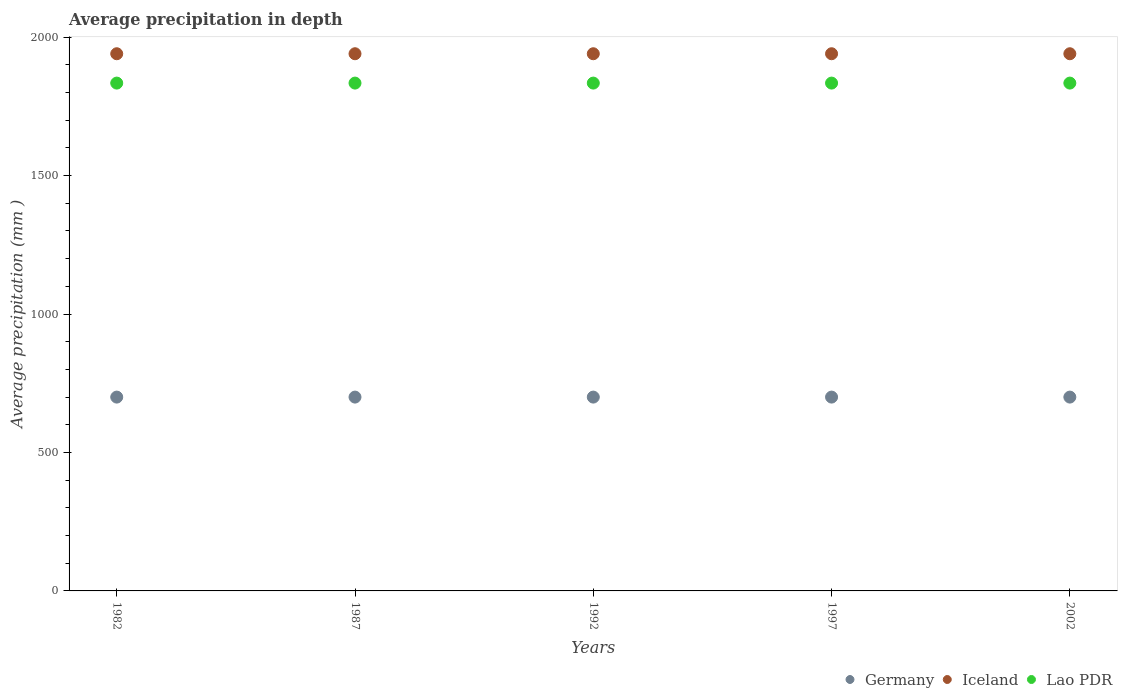What is the average precipitation in Lao PDR in 2002?
Your answer should be compact. 1834. Across all years, what is the maximum average precipitation in Lao PDR?
Ensure brevity in your answer.  1834. Across all years, what is the minimum average precipitation in Iceland?
Offer a very short reply. 1940. In which year was the average precipitation in Germany maximum?
Your answer should be compact. 1982. In which year was the average precipitation in Lao PDR minimum?
Your answer should be very brief. 1982. What is the total average precipitation in Iceland in the graph?
Your answer should be very brief. 9700. What is the difference between the average precipitation in Iceland in 1982 and that in 1997?
Make the answer very short. 0. What is the difference between the average precipitation in Lao PDR in 2002 and the average precipitation in Iceland in 1982?
Provide a short and direct response. -106. What is the average average precipitation in Iceland per year?
Your answer should be very brief. 1940. In the year 1992, what is the difference between the average precipitation in Germany and average precipitation in Iceland?
Your answer should be compact. -1240. In how many years, is the average precipitation in Iceland greater than 1400 mm?
Offer a very short reply. 5. Is the average precipitation in Iceland in 1982 less than that in 1987?
Provide a short and direct response. No. Is the difference between the average precipitation in Germany in 1982 and 1987 greater than the difference between the average precipitation in Iceland in 1982 and 1987?
Provide a succinct answer. No. What is the difference between the highest and the lowest average precipitation in Germany?
Your response must be concise. 0. In how many years, is the average precipitation in Iceland greater than the average average precipitation in Iceland taken over all years?
Your answer should be very brief. 0. Does the average precipitation in Iceland monotonically increase over the years?
Ensure brevity in your answer.  No. Is the average precipitation in Lao PDR strictly greater than the average precipitation in Iceland over the years?
Provide a succinct answer. No. Is the average precipitation in Lao PDR strictly less than the average precipitation in Germany over the years?
Your answer should be very brief. No. Are the values on the major ticks of Y-axis written in scientific E-notation?
Make the answer very short. No. Where does the legend appear in the graph?
Keep it short and to the point. Bottom right. How many legend labels are there?
Offer a very short reply. 3. What is the title of the graph?
Keep it short and to the point. Average precipitation in depth. Does "Ecuador" appear as one of the legend labels in the graph?
Make the answer very short. No. What is the label or title of the Y-axis?
Give a very brief answer. Average precipitation (mm ). What is the Average precipitation (mm ) of Germany in 1982?
Give a very brief answer. 700. What is the Average precipitation (mm ) in Iceland in 1982?
Your answer should be very brief. 1940. What is the Average precipitation (mm ) of Lao PDR in 1982?
Your answer should be compact. 1834. What is the Average precipitation (mm ) in Germany in 1987?
Your answer should be compact. 700. What is the Average precipitation (mm ) of Iceland in 1987?
Your answer should be compact. 1940. What is the Average precipitation (mm ) of Lao PDR in 1987?
Make the answer very short. 1834. What is the Average precipitation (mm ) of Germany in 1992?
Give a very brief answer. 700. What is the Average precipitation (mm ) of Iceland in 1992?
Your response must be concise. 1940. What is the Average precipitation (mm ) in Lao PDR in 1992?
Offer a very short reply. 1834. What is the Average precipitation (mm ) in Germany in 1997?
Make the answer very short. 700. What is the Average precipitation (mm ) in Iceland in 1997?
Your answer should be compact. 1940. What is the Average precipitation (mm ) of Lao PDR in 1997?
Give a very brief answer. 1834. What is the Average precipitation (mm ) of Germany in 2002?
Give a very brief answer. 700. What is the Average precipitation (mm ) of Iceland in 2002?
Offer a terse response. 1940. What is the Average precipitation (mm ) in Lao PDR in 2002?
Offer a terse response. 1834. Across all years, what is the maximum Average precipitation (mm ) of Germany?
Offer a terse response. 700. Across all years, what is the maximum Average precipitation (mm ) in Iceland?
Offer a very short reply. 1940. Across all years, what is the maximum Average precipitation (mm ) in Lao PDR?
Your answer should be compact. 1834. Across all years, what is the minimum Average precipitation (mm ) of Germany?
Keep it short and to the point. 700. Across all years, what is the minimum Average precipitation (mm ) of Iceland?
Give a very brief answer. 1940. Across all years, what is the minimum Average precipitation (mm ) in Lao PDR?
Provide a short and direct response. 1834. What is the total Average precipitation (mm ) of Germany in the graph?
Offer a very short reply. 3500. What is the total Average precipitation (mm ) in Iceland in the graph?
Make the answer very short. 9700. What is the total Average precipitation (mm ) of Lao PDR in the graph?
Offer a terse response. 9170. What is the difference between the Average precipitation (mm ) of Germany in 1982 and that in 1987?
Your answer should be compact. 0. What is the difference between the Average precipitation (mm ) in Iceland in 1982 and that in 1987?
Offer a terse response. 0. What is the difference between the Average precipitation (mm ) of Iceland in 1982 and that in 1992?
Your answer should be very brief. 0. What is the difference between the Average precipitation (mm ) in Iceland in 1982 and that in 1997?
Your response must be concise. 0. What is the difference between the Average precipitation (mm ) in Germany in 1982 and that in 2002?
Provide a short and direct response. 0. What is the difference between the Average precipitation (mm ) in Iceland in 1982 and that in 2002?
Offer a very short reply. 0. What is the difference between the Average precipitation (mm ) in Lao PDR in 1982 and that in 2002?
Ensure brevity in your answer.  0. What is the difference between the Average precipitation (mm ) in Germany in 1987 and that in 1992?
Offer a very short reply. 0. What is the difference between the Average precipitation (mm ) in Iceland in 1987 and that in 1992?
Offer a terse response. 0. What is the difference between the Average precipitation (mm ) in Lao PDR in 1987 and that in 1992?
Ensure brevity in your answer.  0. What is the difference between the Average precipitation (mm ) of Iceland in 1987 and that in 1997?
Your answer should be very brief. 0. What is the difference between the Average precipitation (mm ) of Lao PDR in 1987 and that in 2002?
Ensure brevity in your answer.  0. What is the difference between the Average precipitation (mm ) of Germany in 1992 and that in 1997?
Provide a succinct answer. 0. What is the difference between the Average precipitation (mm ) in Iceland in 1992 and that in 2002?
Make the answer very short. 0. What is the difference between the Average precipitation (mm ) of Germany in 1997 and that in 2002?
Provide a succinct answer. 0. What is the difference between the Average precipitation (mm ) in Lao PDR in 1997 and that in 2002?
Provide a succinct answer. 0. What is the difference between the Average precipitation (mm ) of Germany in 1982 and the Average precipitation (mm ) of Iceland in 1987?
Your answer should be very brief. -1240. What is the difference between the Average precipitation (mm ) of Germany in 1982 and the Average precipitation (mm ) of Lao PDR in 1987?
Give a very brief answer. -1134. What is the difference between the Average precipitation (mm ) in Iceland in 1982 and the Average precipitation (mm ) in Lao PDR in 1987?
Provide a short and direct response. 106. What is the difference between the Average precipitation (mm ) in Germany in 1982 and the Average precipitation (mm ) in Iceland in 1992?
Offer a terse response. -1240. What is the difference between the Average precipitation (mm ) in Germany in 1982 and the Average precipitation (mm ) in Lao PDR in 1992?
Provide a short and direct response. -1134. What is the difference between the Average precipitation (mm ) in Iceland in 1982 and the Average precipitation (mm ) in Lao PDR in 1992?
Offer a terse response. 106. What is the difference between the Average precipitation (mm ) in Germany in 1982 and the Average precipitation (mm ) in Iceland in 1997?
Your answer should be very brief. -1240. What is the difference between the Average precipitation (mm ) in Germany in 1982 and the Average precipitation (mm ) in Lao PDR in 1997?
Your answer should be very brief. -1134. What is the difference between the Average precipitation (mm ) of Iceland in 1982 and the Average precipitation (mm ) of Lao PDR in 1997?
Offer a terse response. 106. What is the difference between the Average precipitation (mm ) of Germany in 1982 and the Average precipitation (mm ) of Iceland in 2002?
Keep it short and to the point. -1240. What is the difference between the Average precipitation (mm ) of Germany in 1982 and the Average precipitation (mm ) of Lao PDR in 2002?
Your response must be concise. -1134. What is the difference between the Average precipitation (mm ) of Iceland in 1982 and the Average precipitation (mm ) of Lao PDR in 2002?
Ensure brevity in your answer.  106. What is the difference between the Average precipitation (mm ) of Germany in 1987 and the Average precipitation (mm ) of Iceland in 1992?
Provide a short and direct response. -1240. What is the difference between the Average precipitation (mm ) in Germany in 1987 and the Average precipitation (mm ) in Lao PDR in 1992?
Offer a terse response. -1134. What is the difference between the Average precipitation (mm ) of Iceland in 1987 and the Average precipitation (mm ) of Lao PDR in 1992?
Offer a very short reply. 106. What is the difference between the Average precipitation (mm ) in Germany in 1987 and the Average precipitation (mm ) in Iceland in 1997?
Offer a terse response. -1240. What is the difference between the Average precipitation (mm ) of Germany in 1987 and the Average precipitation (mm ) of Lao PDR in 1997?
Provide a succinct answer. -1134. What is the difference between the Average precipitation (mm ) of Iceland in 1987 and the Average precipitation (mm ) of Lao PDR in 1997?
Your answer should be compact. 106. What is the difference between the Average precipitation (mm ) in Germany in 1987 and the Average precipitation (mm ) in Iceland in 2002?
Provide a succinct answer. -1240. What is the difference between the Average precipitation (mm ) in Germany in 1987 and the Average precipitation (mm ) in Lao PDR in 2002?
Provide a succinct answer. -1134. What is the difference between the Average precipitation (mm ) of Iceland in 1987 and the Average precipitation (mm ) of Lao PDR in 2002?
Make the answer very short. 106. What is the difference between the Average precipitation (mm ) of Germany in 1992 and the Average precipitation (mm ) of Iceland in 1997?
Your answer should be very brief. -1240. What is the difference between the Average precipitation (mm ) of Germany in 1992 and the Average precipitation (mm ) of Lao PDR in 1997?
Ensure brevity in your answer.  -1134. What is the difference between the Average precipitation (mm ) in Iceland in 1992 and the Average precipitation (mm ) in Lao PDR in 1997?
Ensure brevity in your answer.  106. What is the difference between the Average precipitation (mm ) of Germany in 1992 and the Average precipitation (mm ) of Iceland in 2002?
Your response must be concise. -1240. What is the difference between the Average precipitation (mm ) in Germany in 1992 and the Average precipitation (mm ) in Lao PDR in 2002?
Ensure brevity in your answer.  -1134. What is the difference between the Average precipitation (mm ) in Iceland in 1992 and the Average precipitation (mm ) in Lao PDR in 2002?
Keep it short and to the point. 106. What is the difference between the Average precipitation (mm ) of Germany in 1997 and the Average precipitation (mm ) of Iceland in 2002?
Your response must be concise. -1240. What is the difference between the Average precipitation (mm ) in Germany in 1997 and the Average precipitation (mm ) in Lao PDR in 2002?
Your response must be concise. -1134. What is the difference between the Average precipitation (mm ) of Iceland in 1997 and the Average precipitation (mm ) of Lao PDR in 2002?
Ensure brevity in your answer.  106. What is the average Average precipitation (mm ) of Germany per year?
Offer a terse response. 700. What is the average Average precipitation (mm ) of Iceland per year?
Provide a succinct answer. 1940. What is the average Average precipitation (mm ) in Lao PDR per year?
Provide a short and direct response. 1834. In the year 1982, what is the difference between the Average precipitation (mm ) in Germany and Average precipitation (mm ) in Iceland?
Provide a succinct answer. -1240. In the year 1982, what is the difference between the Average precipitation (mm ) in Germany and Average precipitation (mm ) in Lao PDR?
Offer a very short reply. -1134. In the year 1982, what is the difference between the Average precipitation (mm ) of Iceland and Average precipitation (mm ) of Lao PDR?
Your response must be concise. 106. In the year 1987, what is the difference between the Average precipitation (mm ) of Germany and Average precipitation (mm ) of Iceland?
Your answer should be compact. -1240. In the year 1987, what is the difference between the Average precipitation (mm ) in Germany and Average precipitation (mm ) in Lao PDR?
Ensure brevity in your answer.  -1134. In the year 1987, what is the difference between the Average precipitation (mm ) of Iceland and Average precipitation (mm ) of Lao PDR?
Provide a short and direct response. 106. In the year 1992, what is the difference between the Average precipitation (mm ) of Germany and Average precipitation (mm ) of Iceland?
Provide a short and direct response. -1240. In the year 1992, what is the difference between the Average precipitation (mm ) of Germany and Average precipitation (mm ) of Lao PDR?
Provide a short and direct response. -1134. In the year 1992, what is the difference between the Average precipitation (mm ) in Iceland and Average precipitation (mm ) in Lao PDR?
Offer a terse response. 106. In the year 1997, what is the difference between the Average precipitation (mm ) of Germany and Average precipitation (mm ) of Iceland?
Give a very brief answer. -1240. In the year 1997, what is the difference between the Average precipitation (mm ) in Germany and Average precipitation (mm ) in Lao PDR?
Your response must be concise. -1134. In the year 1997, what is the difference between the Average precipitation (mm ) in Iceland and Average precipitation (mm ) in Lao PDR?
Your answer should be very brief. 106. In the year 2002, what is the difference between the Average precipitation (mm ) of Germany and Average precipitation (mm ) of Iceland?
Make the answer very short. -1240. In the year 2002, what is the difference between the Average precipitation (mm ) in Germany and Average precipitation (mm ) in Lao PDR?
Your response must be concise. -1134. In the year 2002, what is the difference between the Average precipitation (mm ) in Iceland and Average precipitation (mm ) in Lao PDR?
Keep it short and to the point. 106. What is the ratio of the Average precipitation (mm ) of Iceland in 1982 to that in 1987?
Provide a succinct answer. 1. What is the ratio of the Average precipitation (mm ) in Germany in 1982 to that in 1992?
Your answer should be very brief. 1. What is the ratio of the Average precipitation (mm ) of Iceland in 1982 to that in 1992?
Ensure brevity in your answer.  1. What is the ratio of the Average precipitation (mm ) in Germany in 1982 to that in 1997?
Offer a very short reply. 1. What is the ratio of the Average precipitation (mm ) of Iceland in 1982 to that in 1997?
Ensure brevity in your answer.  1. What is the ratio of the Average precipitation (mm ) in Germany in 1982 to that in 2002?
Your answer should be compact. 1. What is the ratio of the Average precipitation (mm ) in Iceland in 1982 to that in 2002?
Your answer should be very brief. 1. What is the ratio of the Average precipitation (mm ) in Germany in 1987 to that in 1992?
Keep it short and to the point. 1. What is the ratio of the Average precipitation (mm ) of Iceland in 1987 to that in 1992?
Ensure brevity in your answer.  1. What is the ratio of the Average precipitation (mm ) in Lao PDR in 1987 to that in 1992?
Give a very brief answer. 1. What is the ratio of the Average precipitation (mm ) in Germany in 1987 to that in 1997?
Keep it short and to the point. 1. What is the ratio of the Average precipitation (mm ) in Iceland in 1987 to that in 1997?
Ensure brevity in your answer.  1. What is the ratio of the Average precipitation (mm ) of Germany in 1987 to that in 2002?
Keep it short and to the point. 1. What is the ratio of the Average precipitation (mm ) in Germany in 1992 to that in 1997?
Your answer should be compact. 1. What is the ratio of the Average precipitation (mm ) of Iceland in 1992 to that in 1997?
Your response must be concise. 1. What is the ratio of the Average precipitation (mm ) in Lao PDR in 1992 to that in 1997?
Offer a very short reply. 1. What is the ratio of the Average precipitation (mm ) of Germany in 1992 to that in 2002?
Keep it short and to the point. 1. What is the ratio of the Average precipitation (mm ) in Germany in 1997 to that in 2002?
Keep it short and to the point. 1. What is the ratio of the Average precipitation (mm ) of Lao PDR in 1997 to that in 2002?
Keep it short and to the point. 1. What is the difference between the highest and the second highest Average precipitation (mm ) of Germany?
Give a very brief answer. 0. What is the difference between the highest and the second highest Average precipitation (mm ) in Lao PDR?
Offer a terse response. 0. What is the difference between the highest and the lowest Average precipitation (mm ) of Germany?
Offer a terse response. 0. What is the difference between the highest and the lowest Average precipitation (mm ) of Lao PDR?
Keep it short and to the point. 0. 